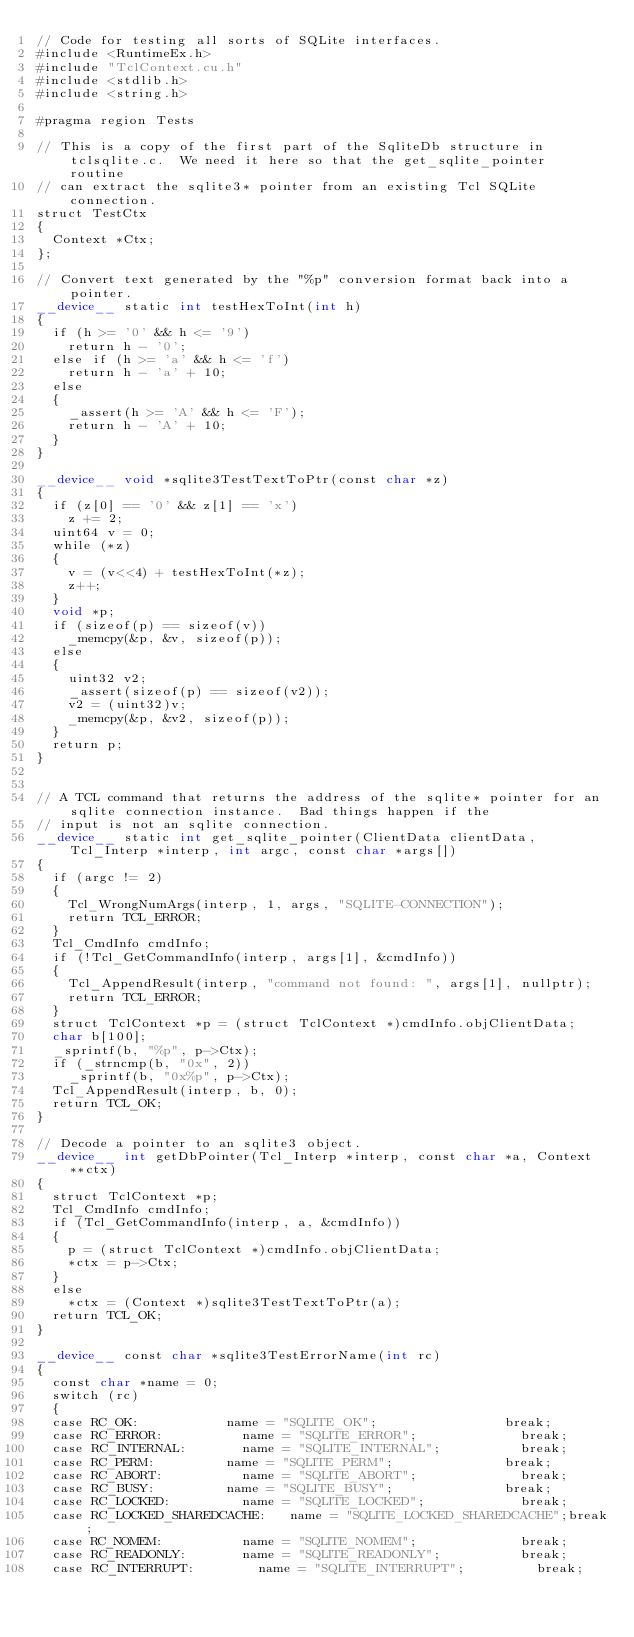Convert code to text. <code><loc_0><loc_0><loc_500><loc_500><_Cuda_>// Code for testing all sorts of SQLite interfaces.
#include <RuntimeEx.h>
#include "TclContext.cu.h"
#include <stdlib.h>
#include <string.h>

#pragma region Tests

// This is a copy of the first part of the SqliteDb structure in tclsqlite.c.  We need it here so that the get_sqlite_pointer routine
// can extract the sqlite3* pointer from an existing Tcl SQLite connection.
struct TestCtx
{
	Context *Ctx;
};

// Convert text generated by the "%p" conversion format back into a pointer.
__device__ static int testHexToInt(int h)
{
	if (h >= '0' && h <= '9')
		return h - '0';
	else if (h >= 'a' && h <= 'f')
		return h - 'a' + 10;
	else
	{
		_assert(h >= 'A' && h <= 'F');
		return h - 'A' + 10;
	}
}

__device__ void *sqlite3TestTextToPtr(const char *z)
{
	if (z[0] == '0' && z[1] == 'x')
		z += 2;
	uint64 v = 0;
	while (*z)
	{
		v = (v<<4) + testHexToInt(*z);
		z++;
	}
	void *p;
	if (sizeof(p) == sizeof(v))
		_memcpy(&p, &v, sizeof(p));
	else
	{
		uint32 v2;
		_assert(sizeof(p) == sizeof(v2));
		v2 = (uint32)v;
		_memcpy(&p, &v2, sizeof(p));
	}
	return p;
}


// A TCL command that returns the address of the sqlite* pointer for an sqlite connection instance.  Bad things happen if the
// input is not an sqlite connection.
__device__ static int get_sqlite_pointer(ClientData clientData, Tcl_Interp *interp, int argc, const char *args[])
{
	if (argc != 2)
	{
		Tcl_WrongNumArgs(interp, 1, args, "SQLITE-CONNECTION");
		return TCL_ERROR;
	}
	Tcl_CmdInfo cmdInfo;
	if (!Tcl_GetCommandInfo(interp, args[1], &cmdInfo))
	{
		Tcl_AppendResult(interp, "command not found: ", args[1], nullptr);
		return TCL_ERROR;
	}
	struct TclContext *p = (struct TclContext *)cmdInfo.objClientData;
	char b[100];
	_sprintf(b, "%p", p->Ctx);
	if (_strncmp(b, "0x", 2))
		_sprintf(b, "0x%p", p->Ctx);
	Tcl_AppendResult(interp, b, 0);
	return TCL_OK;
}

// Decode a pointer to an sqlite3 object.
__device__ int getDbPointer(Tcl_Interp *interp, const char *a, Context **ctx)
{
	struct TclContext *p;
	Tcl_CmdInfo cmdInfo;
	if (Tcl_GetCommandInfo(interp, a, &cmdInfo))
	{
		p = (struct TclContext *)cmdInfo.objClientData;
		*ctx = p->Ctx;
	}
	else
		*ctx = (Context *)sqlite3TestTextToPtr(a);
	return TCL_OK;
}

__device__ const char *sqlite3TestErrorName(int rc)
{
	const char *name = 0;
	switch (rc)
	{
	case RC_OK:						name = "SQLITE_OK";                break;
	case RC_ERROR:					name = "SQLITE_ERROR";             break;
	case RC_INTERNAL:				name = "SQLITE_INTERNAL";          break;
	case RC_PERM:					name = "SQLITE_PERM";              break;
	case RC_ABORT:					name = "SQLITE_ABORT";             break;
	case RC_BUSY:					name = "SQLITE_BUSY";              break;
	case RC_LOCKED:					name = "SQLITE_LOCKED";            break;
	case RC_LOCKED_SHAREDCACHE:		name = "SQLITE_LOCKED_SHAREDCACHE";break;
	case RC_NOMEM:					name = "SQLITE_NOMEM";             break;
	case RC_READONLY:				name = "SQLITE_READONLY";          break;
	case RC_INTERRUPT:				name = "SQLITE_INTERRUPT";         break;</code> 